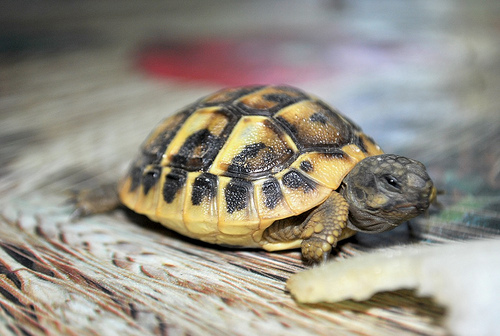<image>
Can you confirm if the head is to the left of the right arm? No. The head is not to the left of the right arm. From this viewpoint, they have a different horizontal relationship. 